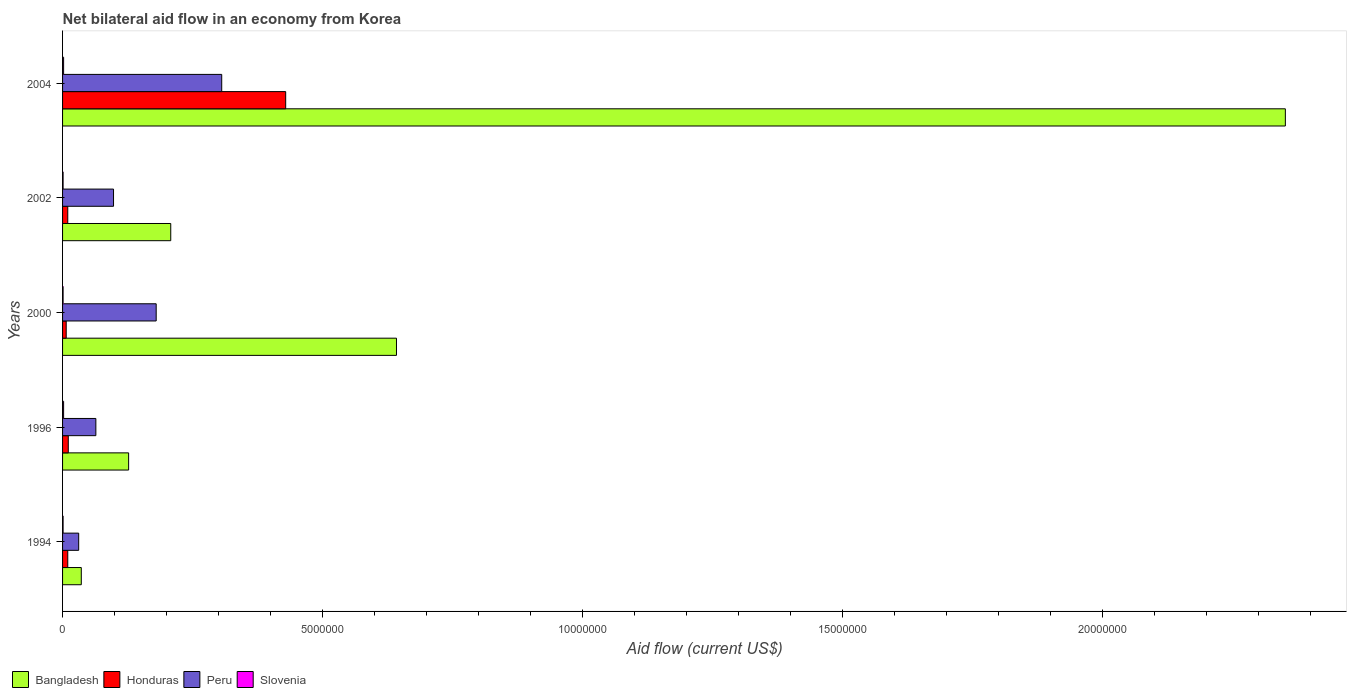In how many cases, is the number of bars for a given year not equal to the number of legend labels?
Your response must be concise. 0. What is the net bilateral aid flow in Honduras in 2002?
Give a very brief answer. 1.00e+05. Across all years, what is the maximum net bilateral aid flow in Peru?
Ensure brevity in your answer.  3.06e+06. What is the total net bilateral aid flow in Peru in the graph?
Offer a very short reply. 6.79e+06. What is the difference between the net bilateral aid flow in Bangladesh in 1994 and that in 1996?
Offer a very short reply. -9.10e+05. What is the difference between the net bilateral aid flow in Bangladesh in 2004 and the net bilateral aid flow in Honduras in 1994?
Your answer should be very brief. 2.34e+07. What is the average net bilateral aid flow in Bangladesh per year?
Your response must be concise. 6.73e+06. In the year 1996, what is the difference between the net bilateral aid flow in Honduras and net bilateral aid flow in Bangladesh?
Give a very brief answer. -1.16e+06. In how many years, is the net bilateral aid flow in Honduras greater than 2000000 US$?
Make the answer very short. 1. What is the difference between the highest and the second highest net bilateral aid flow in Honduras?
Offer a very short reply. 4.18e+06. What is the difference between the highest and the lowest net bilateral aid flow in Honduras?
Provide a succinct answer. 4.22e+06. What does the 3rd bar from the top in 1994 represents?
Ensure brevity in your answer.  Honduras. What does the 4th bar from the bottom in 1994 represents?
Ensure brevity in your answer.  Slovenia. Is it the case that in every year, the sum of the net bilateral aid flow in Peru and net bilateral aid flow in Slovenia is greater than the net bilateral aid flow in Bangladesh?
Provide a short and direct response. No. How many years are there in the graph?
Your response must be concise. 5. What is the difference between two consecutive major ticks on the X-axis?
Your answer should be very brief. 5.00e+06. Does the graph contain any zero values?
Your answer should be very brief. No. How many legend labels are there?
Make the answer very short. 4. How are the legend labels stacked?
Give a very brief answer. Horizontal. What is the title of the graph?
Ensure brevity in your answer.  Net bilateral aid flow in an economy from Korea. Does "Cyprus" appear as one of the legend labels in the graph?
Keep it short and to the point. No. What is the label or title of the X-axis?
Offer a terse response. Aid flow (current US$). What is the Aid flow (current US$) of Bangladesh in 1994?
Offer a terse response. 3.60e+05. What is the Aid flow (current US$) of Slovenia in 1994?
Ensure brevity in your answer.  10000. What is the Aid flow (current US$) of Bangladesh in 1996?
Keep it short and to the point. 1.27e+06. What is the Aid flow (current US$) in Honduras in 1996?
Make the answer very short. 1.10e+05. What is the Aid flow (current US$) of Peru in 1996?
Give a very brief answer. 6.40e+05. What is the Aid flow (current US$) of Bangladesh in 2000?
Keep it short and to the point. 6.42e+06. What is the Aid flow (current US$) of Peru in 2000?
Make the answer very short. 1.80e+06. What is the Aid flow (current US$) of Bangladesh in 2002?
Your answer should be compact. 2.08e+06. What is the Aid flow (current US$) of Peru in 2002?
Your answer should be very brief. 9.80e+05. What is the Aid flow (current US$) in Bangladesh in 2004?
Give a very brief answer. 2.35e+07. What is the Aid flow (current US$) in Honduras in 2004?
Your answer should be compact. 4.29e+06. What is the Aid flow (current US$) in Peru in 2004?
Make the answer very short. 3.06e+06. Across all years, what is the maximum Aid flow (current US$) of Bangladesh?
Provide a short and direct response. 2.35e+07. Across all years, what is the maximum Aid flow (current US$) of Honduras?
Offer a very short reply. 4.29e+06. Across all years, what is the maximum Aid flow (current US$) in Peru?
Offer a terse response. 3.06e+06. Across all years, what is the maximum Aid flow (current US$) of Slovenia?
Ensure brevity in your answer.  2.00e+04. Across all years, what is the minimum Aid flow (current US$) in Bangladesh?
Your answer should be very brief. 3.60e+05. Across all years, what is the minimum Aid flow (current US$) of Honduras?
Make the answer very short. 7.00e+04. Across all years, what is the minimum Aid flow (current US$) in Peru?
Give a very brief answer. 3.10e+05. What is the total Aid flow (current US$) in Bangladesh in the graph?
Offer a terse response. 3.36e+07. What is the total Aid flow (current US$) in Honduras in the graph?
Ensure brevity in your answer.  4.67e+06. What is the total Aid flow (current US$) of Peru in the graph?
Your answer should be compact. 6.79e+06. What is the total Aid flow (current US$) of Slovenia in the graph?
Make the answer very short. 7.00e+04. What is the difference between the Aid flow (current US$) in Bangladesh in 1994 and that in 1996?
Give a very brief answer. -9.10e+05. What is the difference between the Aid flow (current US$) of Honduras in 1994 and that in 1996?
Keep it short and to the point. -10000. What is the difference between the Aid flow (current US$) of Peru in 1994 and that in 1996?
Your response must be concise. -3.30e+05. What is the difference between the Aid flow (current US$) in Slovenia in 1994 and that in 1996?
Provide a succinct answer. -10000. What is the difference between the Aid flow (current US$) of Bangladesh in 1994 and that in 2000?
Provide a succinct answer. -6.06e+06. What is the difference between the Aid flow (current US$) in Peru in 1994 and that in 2000?
Give a very brief answer. -1.49e+06. What is the difference between the Aid flow (current US$) in Bangladesh in 1994 and that in 2002?
Give a very brief answer. -1.72e+06. What is the difference between the Aid flow (current US$) in Peru in 1994 and that in 2002?
Provide a short and direct response. -6.70e+05. What is the difference between the Aid flow (current US$) of Bangladesh in 1994 and that in 2004?
Your response must be concise. -2.32e+07. What is the difference between the Aid flow (current US$) in Honduras in 1994 and that in 2004?
Give a very brief answer. -4.19e+06. What is the difference between the Aid flow (current US$) in Peru in 1994 and that in 2004?
Your response must be concise. -2.75e+06. What is the difference between the Aid flow (current US$) of Bangladesh in 1996 and that in 2000?
Offer a terse response. -5.15e+06. What is the difference between the Aid flow (current US$) of Peru in 1996 and that in 2000?
Give a very brief answer. -1.16e+06. What is the difference between the Aid flow (current US$) of Slovenia in 1996 and that in 2000?
Your answer should be compact. 10000. What is the difference between the Aid flow (current US$) of Bangladesh in 1996 and that in 2002?
Provide a short and direct response. -8.10e+05. What is the difference between the Aid flow (current US$) of Honduras in 1996 and that in 2002?
Offer a terse response. 10000. What is the difference between the Aid flow (current US$) of Slovenia in 1996 and that in 2002?
Provide a short and direct response. 10000. What is the difference between the Aid flow (current US$) in Bangladesh in 1996 and that in 2004?
Ensure brevity in your answer.  -2.22e+07. What is the difference between the Aid flow (current US$) of Honduras in 1996 and that in 2004?
Provide a short and direct response. -4.18e+06. What is the difference between the Aid flow (current US$) of Peru in 1996 and that in 2004?
Provide a succinct answer. -2.42e+06. What is the difference between the Aid flow (current US$) of Slovenia in 1996 and that in 2004?
Your answer should be compact. 0. What is the difference between the Aid flow (current US$) in Bangladesh in 2000 and that in 2002?
Your answer should be compact. 4.34e+06. What is the difference between the Aid flow (current US$) in Honduras in 2000 and that in 2002?
Ensure brevity in your answer.  -3.00e+04. What is the difference between the Aid flow (current US$) in Peru in 2000 and that in 2002?
Offer a terse response. 8.20e+05. What is the difference between the Aid flow (current US$) of Slovenia in 2000 and that in 2002?
Your response must be concise. 0. What is the difference between the Aid flow (current US$) of Bangladesh in 2000 and that in 2004?
Your response must be concise. -1.71e+07. What is the difference between the Aid flow (current US$) of Honduras in 2000 and that in 2004?
Provide a short and direct response. -4.22e+06. What is the difference between the Aid flow (current US$) of Peru in 2000 and that in 2004?
Provide a succinct answer. -1.26e+06. What is the difference between the Aid flow (current US$) of Slovenia in 2000 and that in 2004?
Offer a very short reply. -10000. What is the difference between the Aid flow (current US$) of Bangladesh in 2002 and that in 2004?
Make the answer very short. -2.14e+07. What is the difference between the Aid flow (current US$) of Honduras in 2002 and that in 2004?
Keep it short and to the point. -4.19e+06. What is the difference between the Aid flow (current US$) in Peru in 2002 and that in 2004?
Ensure brevity in your answer.  -2.08e+06. What is the difference between the Aid flow (current US$) in Slovenia in 2002 and that in 2004?
Provide a short and direct response. -10000. What is the difference between the Aid flow (current US$) of Bangladesh in 1994 and the Aid flow (current US$) of Honduras in 1996?
Your answer should be very brief. 2.50e+05. What is the difference between the Aid flow (current US$) in Bangladesh in 1994 and the Aid flow (current US$) in Peru in 1996?
Offer a terse response. -2.80e+05. What is the difference between the Aid flow (current US$) of Bangladesh in 1994 and the Aid flow (current US$) of Slovenia in 1996?
Offer a very short reply. 3.40e+05. What is the difference between the Aid flow (current US$) in Honduras in 1994 and the Aid flow (current US$) in Peru in 1996?
Ensure brevity in your answer.  -5.40e+05. What is the difference between the Aid flow (current US$) of Bangladesh in 1994 and the Aid flow (current US$) of Peru in 2000?
Give a very brief answer. -1.44e+06. What is the difference between the Aid flow (current US$) of Bangladesh in 1994 and the Aid flow (current US$) of Slovenia in 2000?
Make the answer very short. 3.50e+05. What is the difference between the Aid flow (current US$) in Honduras in 1994 and the Aid flow (current US$) in Peru in 2000?
Ensure brevity in your answer.  -1.70e+06. What is the difference between the Aid flow (current US$) in Honduras in 1994 and the Aid flow (current US$) in Slovenia in 2000?
Keep it short and to the point. 9.00e+04. What is the difference between the Aid flow (current US$) in Bangladesh in 1994 and the Aid flow (current US$) in Honduras in 2002?
Your answer should be compact. 2.60e+05. What is the difference between the Aid flow (current US$) in Bangladesh in 1994 and the Aid flow (current US$) in Peru in 2002?
Your answer should be very brief. -6.20e+05. What is the difference between the Aid flow (current US$) in Bangladesh in 1994 and the Aid flow (current US$) in Slovenia in 2002?
Offer a very short reply. 3.50e+05. What is the difference between the Aid flow (current US$) of Honduras in 1994 and the Aid flow (current US$) of Peru in 2002?
Ensure brevity in your answer.  -8.80e+05. What is the difference between the Aid flow (current US$) in Honduras in 1994 and the Aid flow (current US$) in Slovenia in 2002?
Keep it short and to the point. 9.00e+04. What is the difference between the Aid flow (current US$) in Bangladesh in 1994 and the Aid flow (current US$) in Honduras in 2004?
Make the answer very short. -3.93e+06. What is the difference between the Aid flow (current US$) of Bangladesh in 1994 and the Aid flow (current US$) of Peru in 2004?
Give a very brief answer. -2.70e+06. What is the difference between the Aid flow (current US$) in Bangladesh in 1994 and the Aid flow (current US$) in Slovenia in 2004?
Provide a short and direct response. 3.40e+05. What is the difference between the Aid flow (current US$) of Honduras in 1994 and the Aid flow (current US$) of Peru in 2004?
Ensure brevity in your answer.  -2.96e+06. What is the difference between the Aid flow (current US$) of Bangladesh in 1996 and the Aid flow (current US$) of Honduras in 2000?
Your answer should be very brief. 1.20e+06. What is the difference between the Aid flow (current US$) of Bangladesh in 1996 and the Aid flow (current US$) of Peru in 2000?
Keep it short and to the point. -5.30e+05. What is the difference between the Aid flow (current US$) of Bangladesh in 1996 and the Aid flow (current US$) of Slovenia in 2000?
Keep it short and to the point. 1.26e+06. What is the difference between the Aid flow (current US$) of Honduras in 1996 and the Aid flow (current US$) of Peru in 2000?
Give a very brief answer. -1.69e+06. What is the difference between the Aid flow (current US$) of Peru in 1996 and the Aid flow (current US$) of Slovenia in 2000?
Give a very brief answer. 6.30e+05. What is the difference between the Aid flow (current US$) of Bangladesh in 1996 and the Aid flow (current US$) of Honduras in 2002?
Offer a very short reply. 1.17e+06. What is the difference between the Aid flow (current US$) in Bangladesh in 1996 and the Aid flow (current US$) in Peru in 2002?
Provide a succinct answer. 2.90e+05. What is the difference between the Aid flow (current US$) of Bangladesh in 1996 and the Aid flow (current US$) of Slovenia in 2002?
Keep it short and to the point. 1.26e+06. What is the difference between the Aid flow (current US$) in Honduras in 1996 and the Aid flow (current US$) in Peru in 2002?
Your answer should be compact. -8.70e+05. What is the difference between the Aid flow (current US$) of Peru in 1996 and the Aid flow (current US$) of Slovenia in 2002?
Ensure brevity in your answer.  6.30e+05. What is the difference between the Aid flow (current US$) in Bangladesh in 1996 and the Aid flow (current US$) in Honduras in 2004?
Provide a succinct answer. -3.02e+06. What is the difference between the Aid flow (current US$) of Bangladesh in 1996 and the Aid flow (current US$) of Peru in 2004?
Your response must be concise. -1.79e+06. What is the difference between the Aid flow (current US$) of Bangladesh in 1996 and the Aid flow (current US$) of Slovenia in 2004?
Make the answer very short. 1.25e+06. What is the difference between the Aid flow (current US$) in Honduras in 1996 and the Aid flow (current US$) in Peru in 2004?
Provide a succinct answer. -2.95e+06. What is the difference between the Aid flow (current US$) of Peru in 1996 and the Aid flow (current US$) of Slovenia in 2004?
Your answer should be very brief. 6.20e+05. What is the difference between the Aid flow (current US$) in Bangladesh in 2000 and the Aid flow (current US$) in Honduras in 2002?
Your response must be concise. 6.32e+06. What is the difference between the Aid flow (current US$) in Bangladesh in 2000 and the Aid flow (current US$) in Peru in 2002?
Give a very brief answer. 5.44e+06. What is the difference between the Aid flow (current US$) of Bangladesh in 2000 and the Aid flow (current US$) of Slovenia in 2002?
Provide a succinct answer. 6.41e+06. What is the difference between the Aid flow (current US$) in Honduras in 2000 and the Aid flow (current US$) in Peru in 2002?
Offer a very short reply. -9.10e+05. What is the difference between the Aid flow (current US$) in Peru in 2000 and the Aid flow (current US$) in Slovenia in 2002?
Give a very brief answer. 1.79e+06. What is the difference between the Aid flow (current US$) in Bangladesh in 2000 and the Aid flow (current US$) in Honduras in 2004?
Make the answer very short. 2.13e+06. What is the difference between the Aid flow (current US$) in Bangladesh in 2000 and the Aid flow (current US$) in Peru in 2004?
Provide a succinct answer. 3.36e+06. What is the difference between the Aid flow (current US$) in Bangladesh in 2000 and the Aid flow (current US$) in Slovenia in 2004?
Offer a very short reply. 6.40e+06. What is the difference between the Aid flow (current US$) of Honduras in 2000 and the Aid flow (current US$) of Peru in 2004?
Provide a short and direct response. -2.99e+06. What is the difference between the Aid flow (current US$) of Peru in 2000 and the Aid flow (current US$) of Slovenia in 2004?
Keep it short and to the point. 1.78e+06. What is the difference between the Aid flow (current US$) in Bangladesh in 2002 and the Aid flow (current US$) in Honduras in 2004?
Give a very brief answer. -2.21e+06. What is the difference between the Aid flow (current US$) in Bangladesh in 2002 and the Aid flow (current US$) in Peru in 2004?
Your response must be concise. -9.80e+05. What is the difference between the Aid flow (current US$) of Bangladesh in 2002 and the Aid flow (current US$) of Slovenia in 2004?
Ensure brevity in your answer.  2.06e+06. What is the difference between the Aid flow (current US$) in Honduras in 2002 and the Aid flow (current US$) in Peru in 2004?
Give a very brief answer. -2.96e+06. What is the difference between the Aid flow (current US$) in Honduras in 2002 and the Aid flow (current US$) in Slovenia in 2004?
Give a very brief answer. 8.00e+04. What is the difference between the Aid flow (current US$) in Peru in 2002 and the Aid flow (current US$) in Slovenia in 2004?
Keep it short and to the point. 9.60e+05. What is the average Aid flow (current US$) in Bangladesh per year?
Provide a succinct answer. 6.73e+06. What is the average Aid flow (current US$) of Honduras per year?
Make the answer very short. 9.34e+05. What is the average Aid flow (current US$) in Peru per year?
Give a very brief answer. 1.36e+06. What is the average Aid flow (current US$) of Slovenia per year?
Ensure brevity in your answer.  1.40e+04. In the year 1994, what is the difference between the Aid flow (current US$) of Bangladesh and Aid flow (current US$) of Honduras?
Your answer should be very brief. 2.60e+05. In the year 1994, what is the difference between the Aid flow (current US$) in Bangladesh and Aid flow (current US$) in Peru?
Provide a short and direct response. 5.00e+04. In the year 1994, what is the difference between the Aid flow (current US$) of Honduras and Aid flow (current US$) of Peru?
Give a very brief answer. -2.10e+05. In the year 1994, what is the difference between the Aid flow (current US$) in Honduras and Aid flow (current US$) in Slovenia?
Make the answer very short. 9.00e+04. In the year 1996, what is the difference between the Aid flow (current US$) of Bangladesh and Aid flow (current US$) of Honduras?
Offer a very short reply. 1.16e+06. In the year 1996, what is the difference between the Aid flow (current US$) in Bangladesh and Aid flow (current US$) in Peru?
Offer a very short reply. 6.30e+05. In the year 1996, what is the difference between the Aid flow (current US$) of Bangladesh and Aid flow (current US$) of Slovenia?
Your answer should be compact. 1.25e+06. In the year 1996, what is the difference between the Aid flow (current US$) in Honduras and Aid flow (current US$) in Peru?
Give a very brief answer. -5.30e+05. In the year 1996, what is the difference between the Aid flow (current US$) in Peru and Aid flow (current US$) in Slovenia?
Provide a short and direct response. 6.20e+05. In the year 2000, what is the difference between the Aid flow (current US$) of Bangladesh and Aid flow (current US$) of Honduras?
Your response must be concise. 6.35e+06. In the year 2000, what is the difference between the Aid flow (current US$) in Bangladesh and Aid flow (current US$) in Peru?
Provide a succinct answer. 4.62e+06. In the year 2000, what is the difference between the Aid flow (current US$) of Bangladesh and Aid flow (current US$) of Slovenia?
Your response must be concise. 6.41e+06. In the year 2000, what is the difference between the Aid flow (current US$) of Honduras and Aid flow (current US$) of Peru?
Offer a terse response. -1.73e+06. In the year 2000, what is the difference between the Aid flow (current US$) in Peru and Aid flow (current US$) in Slovenia?
Your answer should be very brief. 1.79e+06. In the year 2002, what is the difference between the Aid flow (current US$) of Bangladesh and Aid flow (current US$) of Honduras?
Offer a very short reply. 1.98e+06. In the year 2002, what is the difference between the Aid flow (current US$) in Bangladesh and Aid flow (current US$) in Peru?
Your answer should be compact. 1.10e+06. In the year 2002, what is the difference between the Aid flow (current US$) of Bangladesh and Aid flow (current US$) of Slovenia?
Offer a terse response. 2.07e+06. In the year 2002, what is the difference between the Aid flow (current US$) of Honduras and Aid flow (current US$) of Peru?
Offer a terse response. -8.80e+05. In the year 2002, what is the difference between the Aid flow (current US$) in Honduras and Aid flow (current US$) in Slovenia?
Give a very brief answer. 9.00e+04. In the year 2002, what is the difference between the Aid flow (current US$) of Peru and Aid flow (current US$) of Slovenia?
Provide a succinct answer. 9.70e+05. In the year 2004, what is the difference between the Aid flow (current US$) in Bangladesh and Aid flow (current US$) in Honduras?
Offer a very short reply. 1.92e+07. In the year 2004, what is the difference between the Aid flow (current US$) of Bangladesh and Aid flow (current US$) of Peru?
Offer a very short reply. 2.04e+07. In the year 2004, what is the difference between the Aid flow (current US$) in Bangladesh and Aid flow (current US$) in Slovenia?
Ensure brevity in your answer.  2.35e+07. In the year 2004, what is the difference between the Aid flow (current US$) of Honduras and Aid flow (current US$) of Peru?
Provide a succinct answer. 1.23e+06. In the year 2004, what is the difference between the Aid flow (current US$) of Honduras and Aid flow (current US$) of Slovenia?
Provide a short and direct response. 4.27e+06. In the year 2004, what is the difference between the Aid flow (current US$) of Peru and Aid flow (current US$) of Slovenia?
Make the answer very short. 3.04e+06. What is the ratio of the Aid flow (current US$) of Bangladesh in 1994 to that in 1996?
Your response must be concise. 0.28. What is the ratio of the Aid flow (current US$) in Peru in 1994 to that in 1996?
Provide a short and direct response. 0.48. What is the ratio of the Aid flow (current US$) of Slovenia in 1994 to that in 1996?
Offer a terse response. 0.5. What is the ratio of the Aid flow (current US$) of Bangladesh in 1994 to that in 2000?
Offer a very short reply. 0.06. What is the ratio of the Aid flow (current US$) in Honduras in 1994 to that in 2000?
Your answer should be very brief. 1.43. What is the ratio of the Aid flow (current US$) in Peru in 1994 to that in 2000?
Your answer should be compact. 0.17. What is the ratio of the Aid flow (current US$) in Bangladesh in 1994 to that in 2002?
Your answer should be very brief. 0.17. What is the ratio of the Aid flow (current US$) in Peru in 1994 to that in 2002?
Provide a short and direct response. 0.32. What is the ratio of the Aid flow (current US$) in Bangladesh in 1994 to that in 2004?
Give a very brief answer. 0.02. What is the ratio of the Aid flow (current US$) in Honduras in 1994 to that in 2004?
Offer a terse response. 0.02. What is the ratio of the Aid flow (current US$) of Peru in 1994 to that in 2004?
Your answer should be very brief. 0.1. What is the ratio of the Aid flow (current US$) in Slovenia in 1994 to that in 2004?
Keep it short and to the point. 0.5. What is the ratio of the Aid flow (current US$) in Bangladesh in 1996 to that in 2000?
Keep it short and to the point. 0.2. What is the ratio of the Aid flow (current US$) of Honduras in 1996 to that in 2000?
Give a very brief answer. 1.57. What is the ratio of the Aid flow (current US$) in Peru in 1996 to that in 2000?
Give a very brief answer. 0.36. What is the ratio of the Aid flow (current US$) of Slovenia in 1996 to that in 2000?
Your answer should be compact. 2. What is the ratio of the Aid flow (current US$) in Bangladesh in 1996 to that in 2002?
Provide a succinct answer. 0.61. What is the ratio of the Aid flow (current US$) in Peru in 1996 to that in 2002?
Your answer should be compact. 0.65. What is the ratio of the Aid flow (current US$) in Bangladesh in 1996 to that in 2004?
Make the answer very short. 0.05. What is the ratio of the Aid flow (current US$) in Honduras in 1996 to that in 2004?
Keep it short and to the point. 0.03. What is the ratio of the Aid flow (current US$) in Peru in 1996 to that in 2004?
Your response must be concise. 0.21. What is the ratio of the Aid flow (current US$) of Bangladesh in 2000 to that in 2002?
Keep it short and to the point. 3.09. What is the ratio of the Aid flow (current US$) of Honduras in 2000 to that in 2002?
Offer a very short reply. 0.7. What is the ratio of the Aid flow (current US$) in Peru in 2000 to that in 2002?
Your answer should be compact. 1.84. What is the ratio of the Aid flow (current US$) in Bangladesh in 2000 to that in 2004?
Your answer should be very brief. 0.27. What is the ratio of the Aid flow (current US$) in Honduras in 2000 to that in 2004?
Ensure brevity in your answer.  0.02. What is the ratio of the Aid flow (current US$) in Peru in 2000 to that in 2004?
Your response must be concise. 0.59. What is the ratio of the Aid flow (current US$) in Slovenia in 2000 to that in 2004?
Keep it short and to the point. 0.5. What is the ratio of the Aid flow (current US$) in Bangladesh in 2002 to that in 2004?
Keep it short and to the point. 0.09. What is the ratio of the Aid flow (current US$) of Honduras in 2002 to that in 2004?
Your response must be concise. 0.02. What is the ratio of the Aid flow (current US$) of Peru in 2002 to that in 2004?
Your response must be concise. 0.32. What is the ratio of the Aid flow (current US$) in Slovenia in 2002 to that in 2004?
Ensure brevity in your answer.  0.5. What is the difference between the highest and the second highest Aid flow (current US$) of Bangladesh?
Ensure brevity in your answer.  1.71e+07. What is the difference between the highest and the second highest Aid flow (current US$) in Honduras?
Offer a terse response. 4.18e+06. What is the difference between the highest and the second highest Aid flow (current US$) of Peru?
Offer a very short reply. 1.26e+06. What is the difference between the highest and the lowest Aid flow (current US$) of Bangladesh?
Your answer should be very brief. 2.32e+07. What is the difference between the highest and the lowest Aid flow (current US$) of Honduras?
Give a very brief answer. 4.22e+06. What is the difference between the highest and the lowest Aid flow (current US$) of Peru?
Your answer should be compact. 2.75e+06. What is the difference between the highest and the lowest Aid flow (current US$) of Slovenia?
Offer a terse response. 10000. 